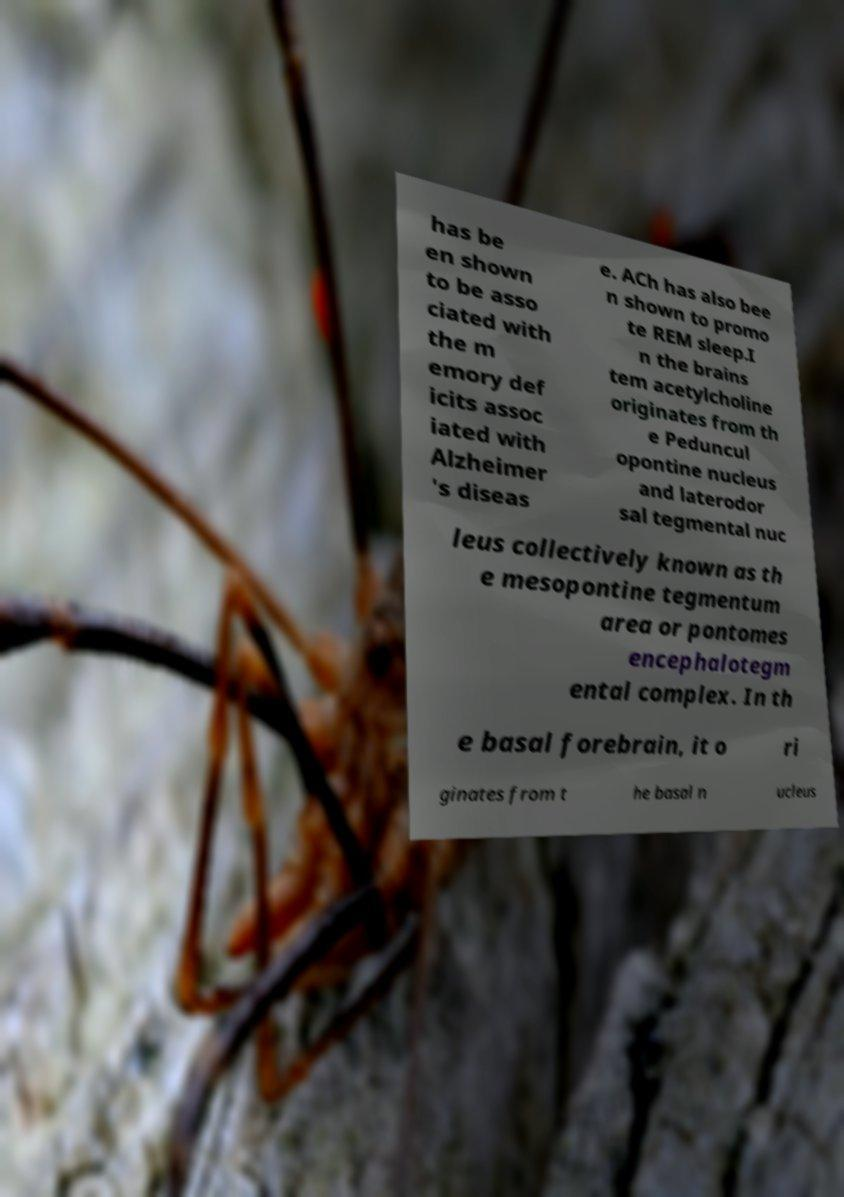Can you accurately transcribe the text from the provided image for me? has be en shown to be asso ciated with the m emory def icits assoc iated with Alzheimer 's diseas e. ACh has also bee n shown to promo te REM sleep.I n the brains tem acetylcholine originates from th e Peduncul opontine nucleus and laterodor sal tegmental nuc leus collectively known as th e mesopontine tegmentum area or pontomes encephalotegm ental complex. In th e basal forebrain, it o ri ginates from t he basal n ucleus 